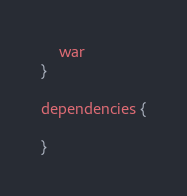<code> <loc_0><loc_0><loc_500><loc_500><_Kotlin_>	war
}

dependencies {

}
</code> 